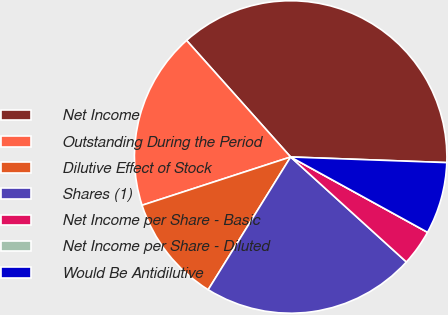<chart> <loc_0><loc_0><loc_500><loc_500><pie_chart><fcel>Net Income<fcel>Outstanding During the Period<fcel>Dilutive Effect of Stock<fcel>Shares (1)<fcel>Net Income per Share - Basic<fcel>Net Income per Share - Diluted<fcel>Would Be Antidilutive<nl><fcel>37.17%<fcel>18.4%<fcel>11.15%<fcel>22.12%<fcel>3.72%<fcel>0.0%<fcel>7.43%<nl></chart> 